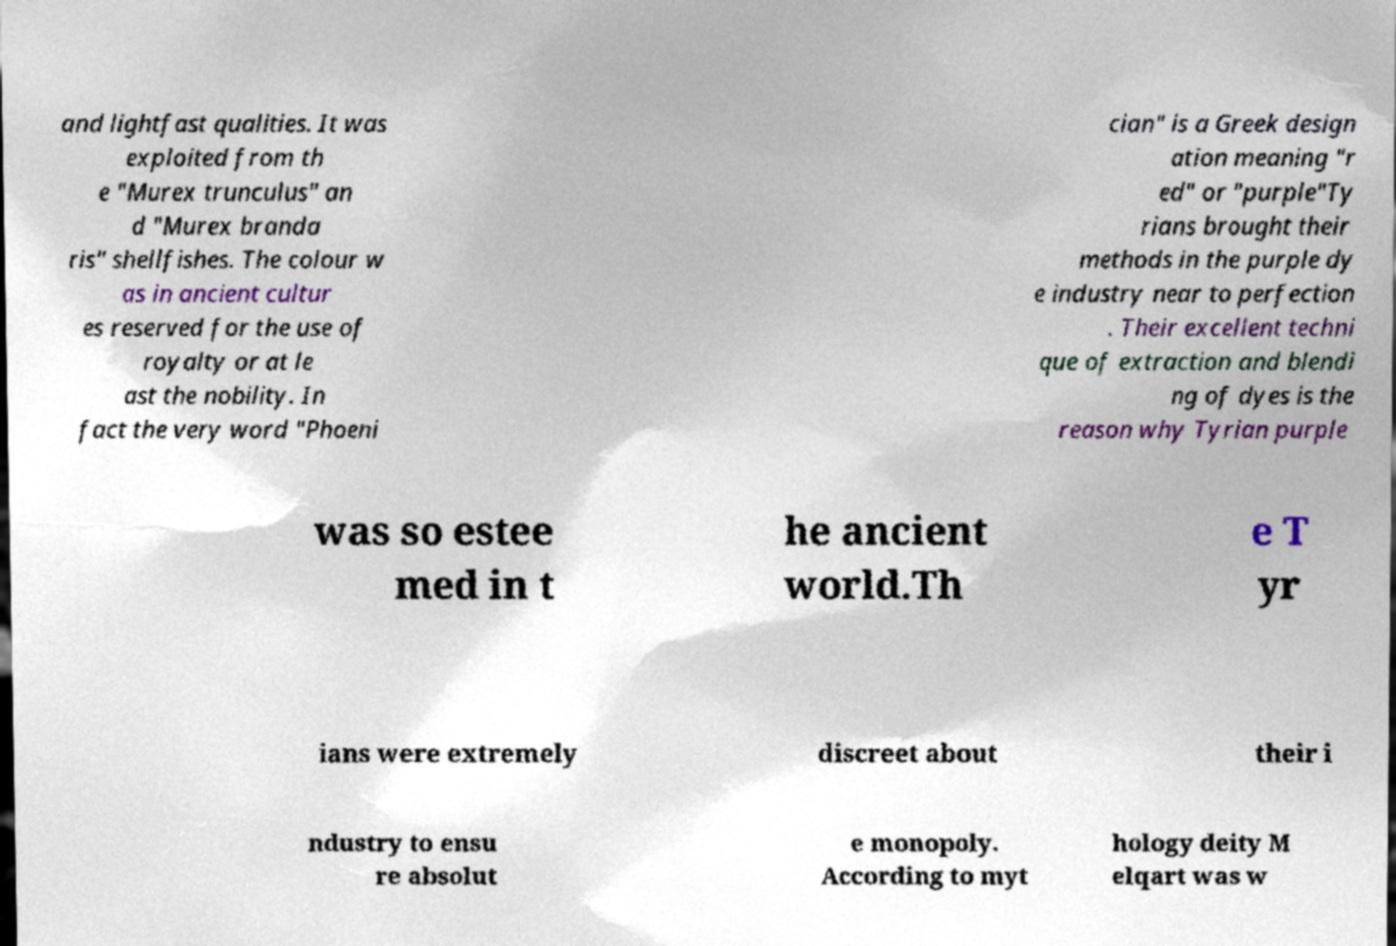There's text embedded in this image that I need extracted. Can you transcribe it verbatim? and lightfast qualities. It was exploited from th e "Murex trunculus" an d "Murex branda ris" shellfishes. The colour w as in ancient cultur es reserved for the use of royalty or at le ast the nobility. In fact the very word "Phoeni cian" is a Greek design ation meaning "r ed" or "purple"Ty rians brought their methods in the purple dy e industry near to perfection . Their excellent techni que of extraction and blendi ng of dyes is the reason why Tyrian purple was so estee med in t he ancient world.Th e T yr ians were extremely discreet about their i ndustry to ensu re absolut e monopoly. According to myt hology deity M elqart was w 